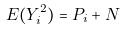<formula> <loc_0><loc_0><loc_500><loc_500>E ( Y _ { i } ^ { 2 } ) = P _ { i } + N</formula> 